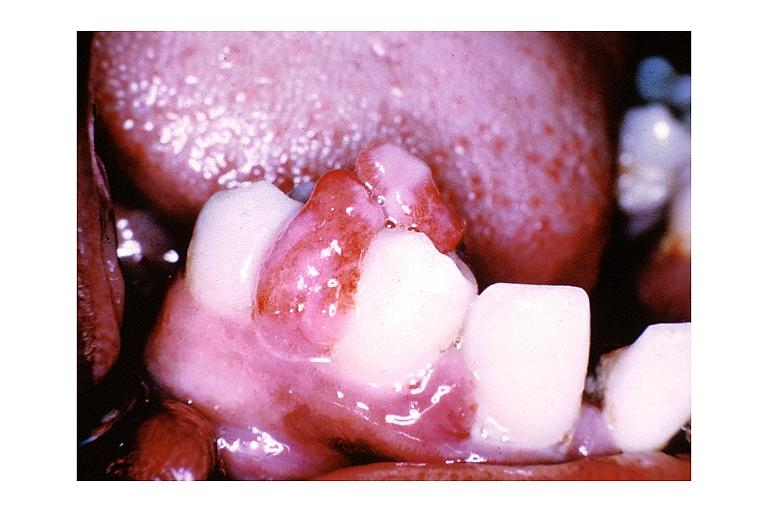where is this?
Answer the question using a single word or phrase. Oral 